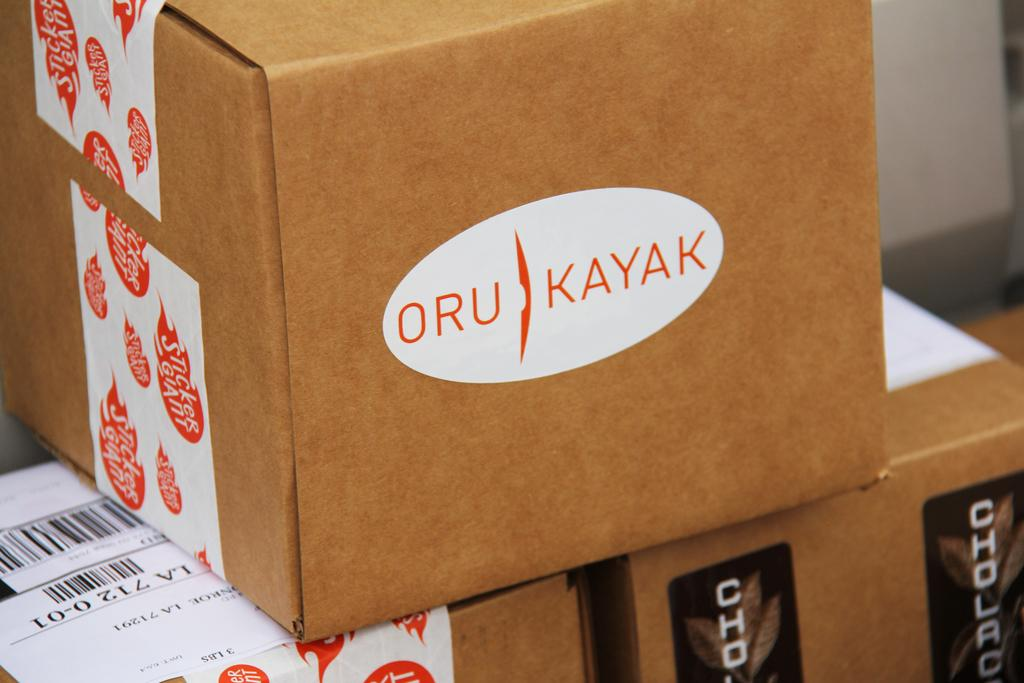<image>
Summarize the visual content of the image. the word Oru is on the brown box 